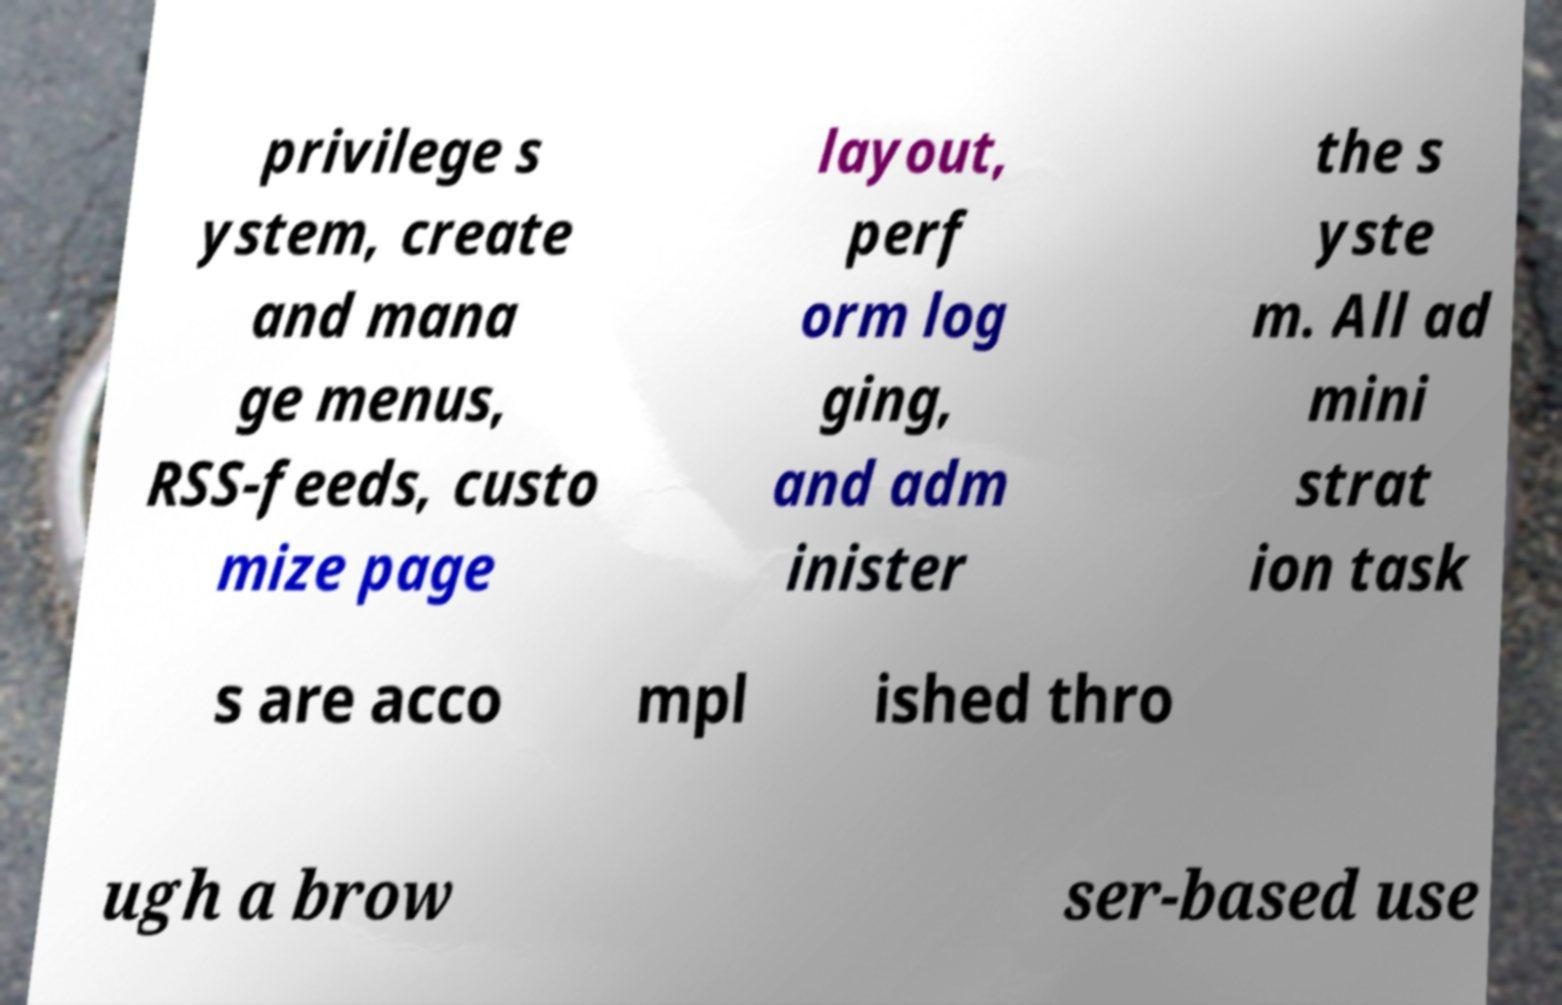Can you accurately transcribe the text from the provided image for me? privilege s ystem, create and mana ge menus, RSS-feeds, custo mize page layout, perf orm log ging, and adm inister the s yste m. All ad mini strat ion task s are acco mpl ished thro ugh a brow ser-based use 